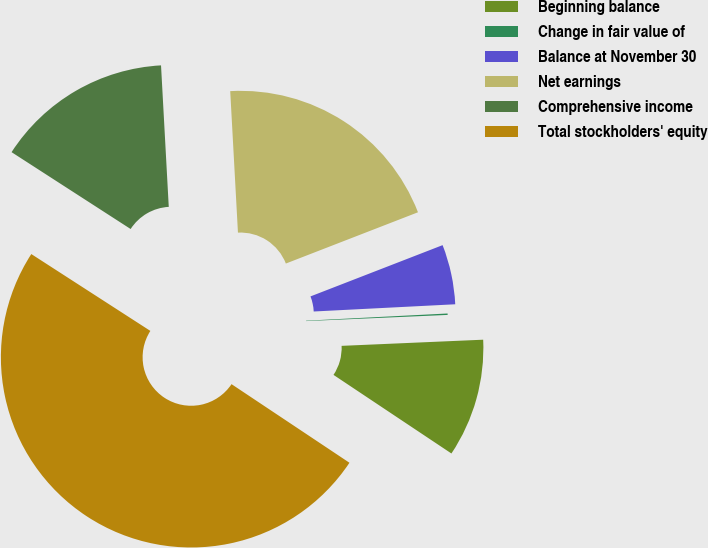Convert chart. <chart><loc_0><loc_0><loc_500><loc_500><pie_chart><fcel>Beginning balance<fcel>Change in fair value of<fcel>Balance at November 30<fcel>Net earnings<fcel>Comprehensive income<fcel>Total stockholders' equity<nl><fcel>10.05%<fcel>0.12%<fcel>5.08%<fcel>19.98%<fcel>15.01%<fcel>49.77%<nl></chart> 